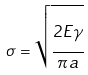<formula> <loc_0><loc_0><loc_500><loc_500>\sigma = { \sqrt { \cfrac { 2 E \gamma } { \pi a } } }</formula> 